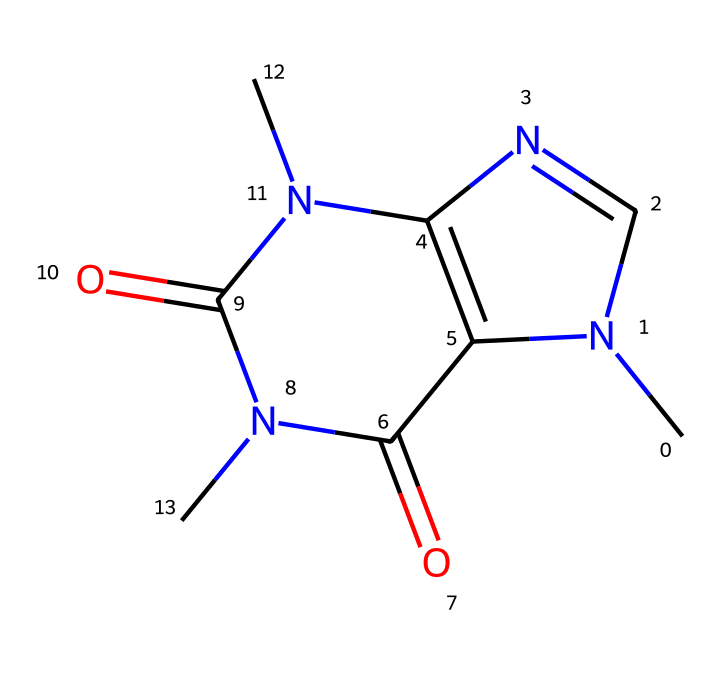What is the total number of nitrogen atoms in the structure? In the provided SMILES representation, we can see the presence of nitrogen atoms represented by 'N'. By examining the structure, we find three nitrogen atoms in total.
Answer: three How many carbon atoms are present in this compound? To determine the number of carbon atoms, we look for the 'C' symbols in the SMILES. Counting all 'C' indicates that there are eight carbon atoms in the structure.
Answer: eight What type of functional groups are present in caffeine? By analyzing the structure, we can identify carbonyl functional groups (C=O) due to the presence of double bonds to oxygen atoms adjacent to the nitrogen. These indicate that caffeine contains imide functional groups as seen in the structure.
Answer: imide Does this molecule have any rings in its structure? Upon examining the SMILES, we notice that 'N1' and 'C2' denote the start of two connected rings. Tracing these connections confirms that caffeine indeed has a bicyclic structure comprising two fused rings.
Answer: yes What is the classification of caffeine among organic compounds? Caffeine possesses properties typical of alkaloids due to the presence of nitrogen and its stimulant effects in biological systems. The nitrogen atoms in a heterocycle further classify it as a nitrogenous base, which is characteristic of alkaloids.
Answer: alkaloid How many carbonyl (C=O) groups are present in this compound? By examining the locations of the double bonds to oxygen, we see that two carbonyl groups are formed in the imide structure of caffeine. Analyzing the entire structure confirms that there are exactly two instances of carbonyls.
Answer: two 